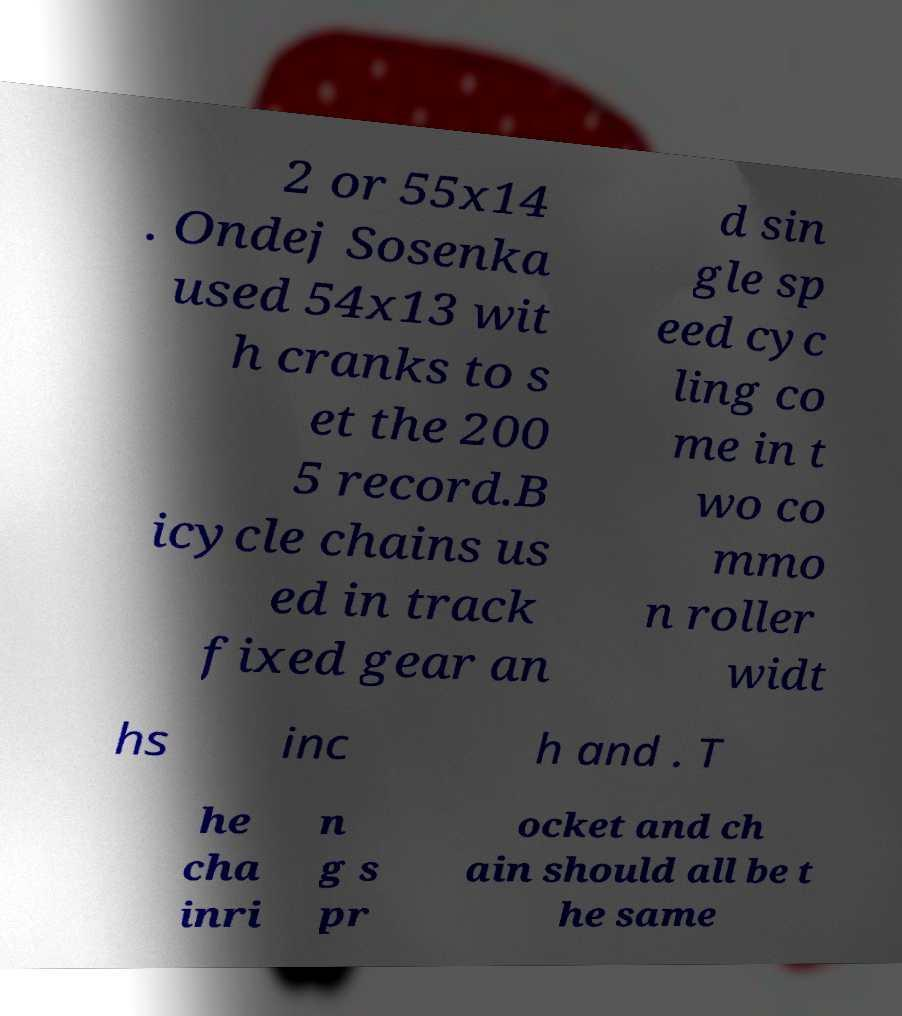Could you assist in decoding the text presented in this image and type it out clearly? 2 or 55x14 . Ondej Sosenka used 54x13 wit h cranks to s et the 200 5 record.B icycle chains us ed in track fixed gear an d sin gle sp eed cyc ling co me in t wo co mmo n roller widt hs inc h and . T he cha inri n g s pr ocket and ch ain should all be t he same 